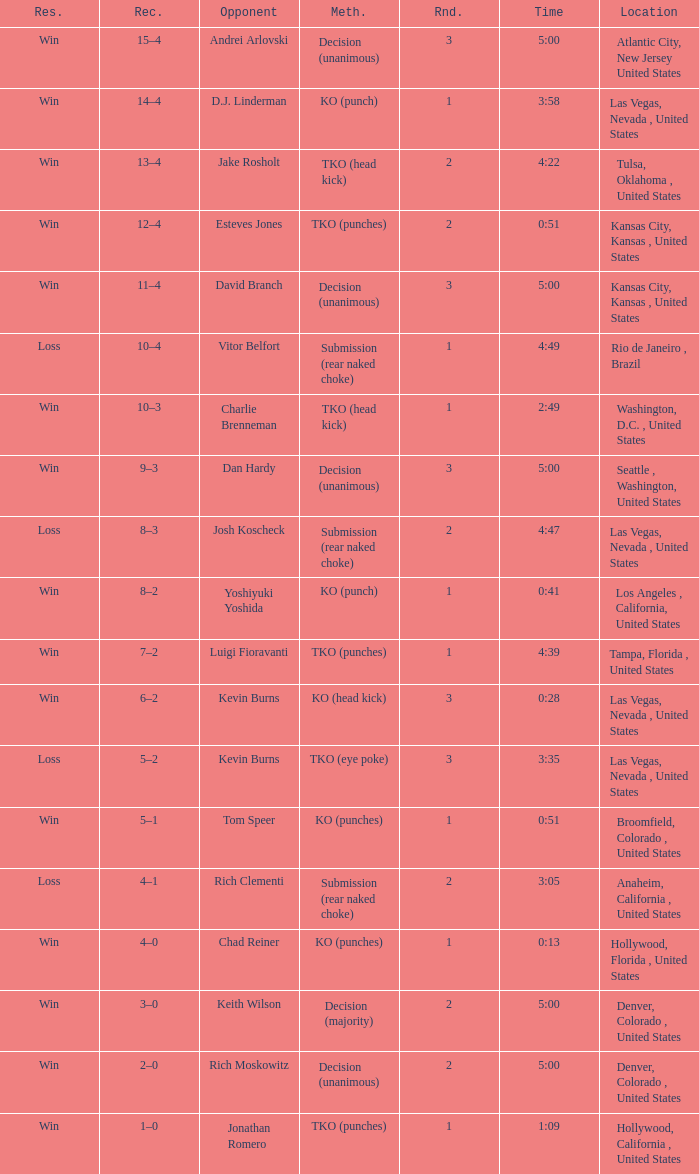Can you parse all the data within this table? {'header': ['Res.', 'Rec.', 'Opponent', 'Meth.', 'Rnd.', 'Time', 'Location'], 'rows': [['Win', '15–4', 'Andrei Arlovski', 'Decision (unanimous)', '3', '5:00', 'Atlantic City, New Jersey United States'], ['Win', '14–4', 'D.J. Linderman', 'KO (punch)', '1', '3:58', 'Las Vegas, Nevada , United States'], ['Win', '13–4', 'Jake Rosholt', 'TKO (head kick)', '2', '4:22', 'Tulsa, Oklahoma , United States'], ['Win', '12–4', 'Esteves Jones', 'TKO (punches)', '2', '0:51', 'Kansas City, Kansas , United States'], ['Win', '11–4', 'David Branch', 'Decision (unanimous)', '3', '5:00', 'Kansas City, Kansas , United States'], ['Loss', '10–4', 'Vitor Belfort', 'Submission (rear naked choke)', '1', '4:49', 'Rio de Janeiro , Brazil'], ['Win', '10–3', 'Charlie Brenneman', 'TKO (head kick)', '1', '2:49', 'Washington, D.C. , United States'], ['Win', '9–3', 'Dan Hardy', 'Decision (unanimous)', '3', '5:00', 'Seattle , Washington, United States'], ['Loss', '8–3', 'Josh Koscheck', 'Submission (rear naked choke)', '2', '4:47', 'Las Vegas, Nevada , United States'], ['Win', '8–2', 'Yoshiyuki Yoshida', 'KO (punch)', '1', '0:41', 'Los Angeles , California, United States'], ['Win', '7–2', 'Luigi Fioravanti', 'TKO (punches)', '1', '4:39', 'Tampa, Florida , United States'], ['Win', '6–2', 'Kevin Burns', 'KO (head kick)', '3', '0:28', 'Las Vegas, Nevada , United States'], ['Loss', '5–2', 'Kevin Burns', 'TKO (eye poke)', '3', '3:35', 'Las Vegas, Nevada , United States'], ['Win', '5–1', 'Tom Speer', 'KO (punches)', '1', '0:51', 'Broomfield, Colorado , United States'], ['Loss', '4–1', 'Rich Clementi', 'Submission (rear naked choke)', '2', '3:05', 'Anaheim, California , United States'], ['Win', '4–0', 'Chad Reiner', 'KO (punches)', '1', '0:13', 'Hollywood, Florida , United States'], ['Win', '3–0', 'Keith Wilson', 'Decision (majority)', '2', '5:00', 'Denver, Colorado , United States'], ['Win', '2–0', 'Rich Moskowitz', 'Decision (unanimous)', '2', '5:00', 'Denver, Colorado , United States'], ['Win', '1–0', 'Jonathan Romero', 'TKO (punches)', '1', '1:09', 'Hollywood, California , United States']]} What is the highest round number with a time of 4:39? 1.0. 